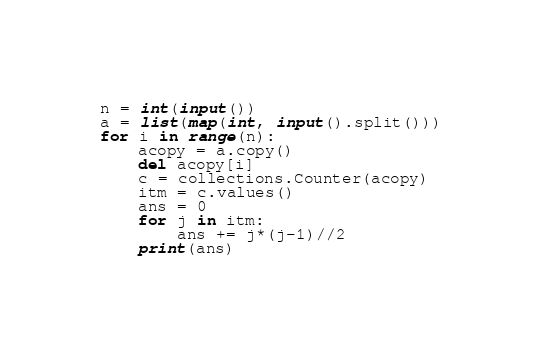<code> <loc_0><loc_0><loc_500><loc_500><_Python_>n = int(input())
a = list(map(int, input().split()))
for i in range(n):
    acopy = a.copy()
    del acopy[i]
    c = collections.Counter(acopy)
    itm = c.values()
    ans = 0
    for j in itm:
        ans += j*(j-1)//2
    print(ans)
</code> 